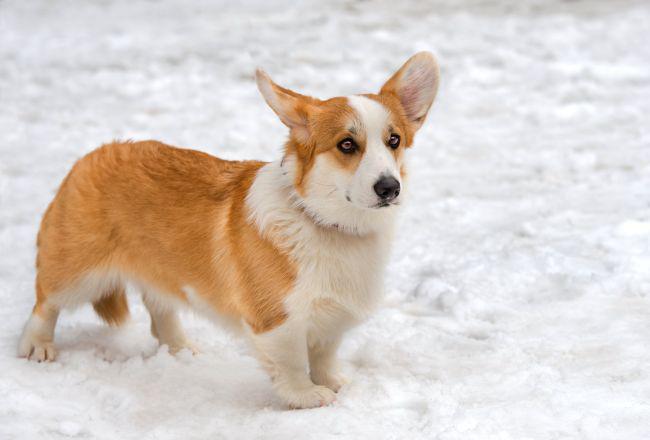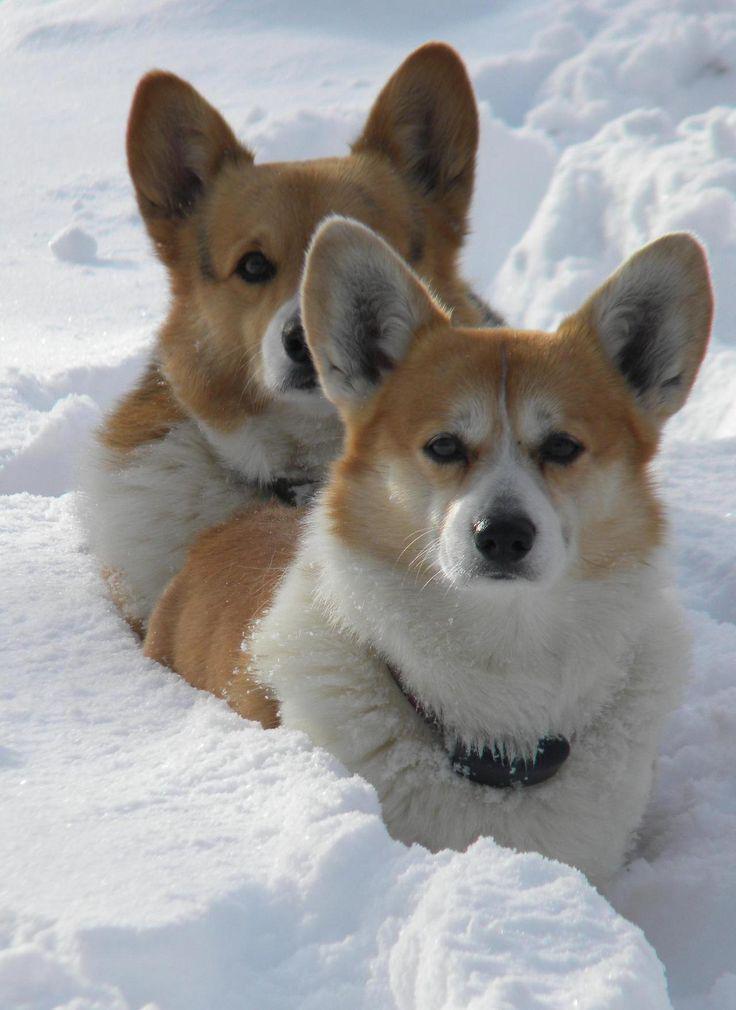The first image is the image on the left, the second image is the image on the right. Examine the images to the left and right. Is the description "There are three dogs in the image pair." accurate? Answer yes or no. Yes. The first image is the image on the left, the second image is the image on the right. Analyze the images presented: Is the assertion "There are exactly 3 dogs." valid? Answer yes or no. Yes. 